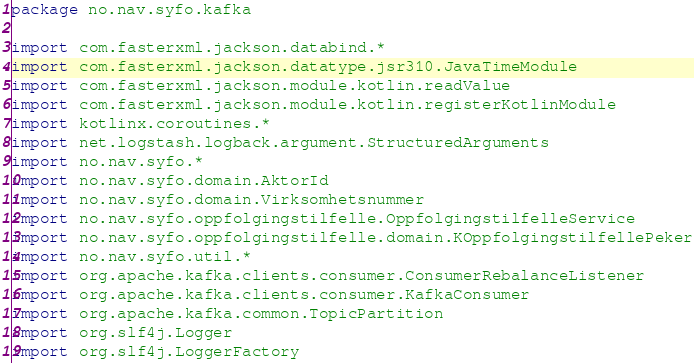Convert code to text. <code><loc_0><loc_0><loc_500><loc_500><_Kotlin_>package no.nav.syfo.kafka

import com.fasterxml.jackson.databind.*
import com.fasterxml.jackson.datatype.jsr310.JavaTimeModule
import com.fasterxml.jackson.module.kotlin.readValue
import com.fasterxml.jackson.module.kotlin.registerKotlinModule
import kotlinx.coroutines.*
import net.logstash.logback.argument.StructuredArguments
import no.nav.syfo.*
import no.nav.syfo.domain.AktorId
import no.nav.syfo.domain.Virksomhetsnummer
import no.nav.syfo.oppfolgingstilfelle.OppfolgingstilfelleService
import no.nav.syfo.oppfolgingstilfelle.domain.KOppfolgingstilfellePeker
import no.nav.syfo.util.*
import org.apache.kafka.clients.consumer.ConsumerRebalanceListener
import org.apache.kafka.clients.consumer.KafkaConsumer
import org.apache.kafka.common.TopicPartition
import org.slf4j.Logger
import org.slf4j.LoggerFactory</code> 